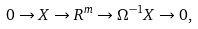<formula> <loc_0><loc_0><loc_500><loc_500>0 \to X \to R ^ { m } \to \Omega ^ { - 1 } X \to 0 ,</formula> 